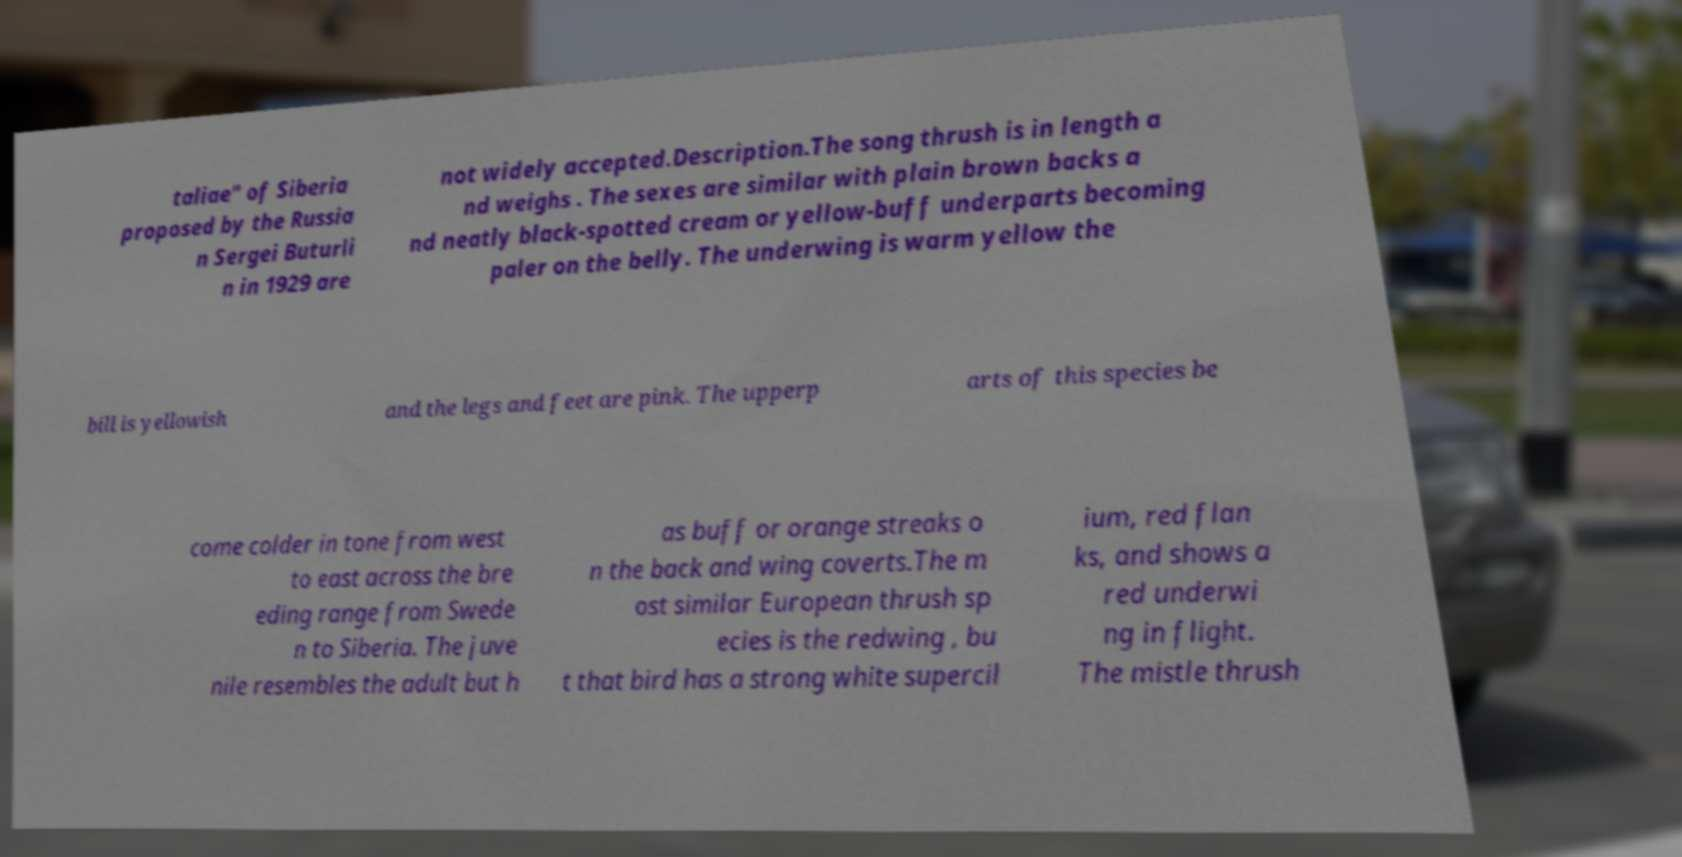I need the written content from this picture converted into text. Can you do that? taliae" of Siberia proposed by the Russia n Sergei Buturli n in 1929 are not widely accepted.Description.The song thrush is in length a nd weighs . The sexes are similar with plain brown backs a nd neatly black-spotted cream or yellow-buff underparts becoming paler on the belly. The underwing is warm yellow the bill is yellowish and the legs and feet are pink. The upperp arts of this species be come colder in tone from west to east across the bre eding range from Swede n to Siberia. The juve nile resembles the adult but h as buff or orange streaks o n the back and wing coverts.The m ost similar European thrush sp ecies is the redwing , bu t that bird has a strong white supercil ium, red flan ks, and shows a red underwi ng in flight. The mistle thrush 